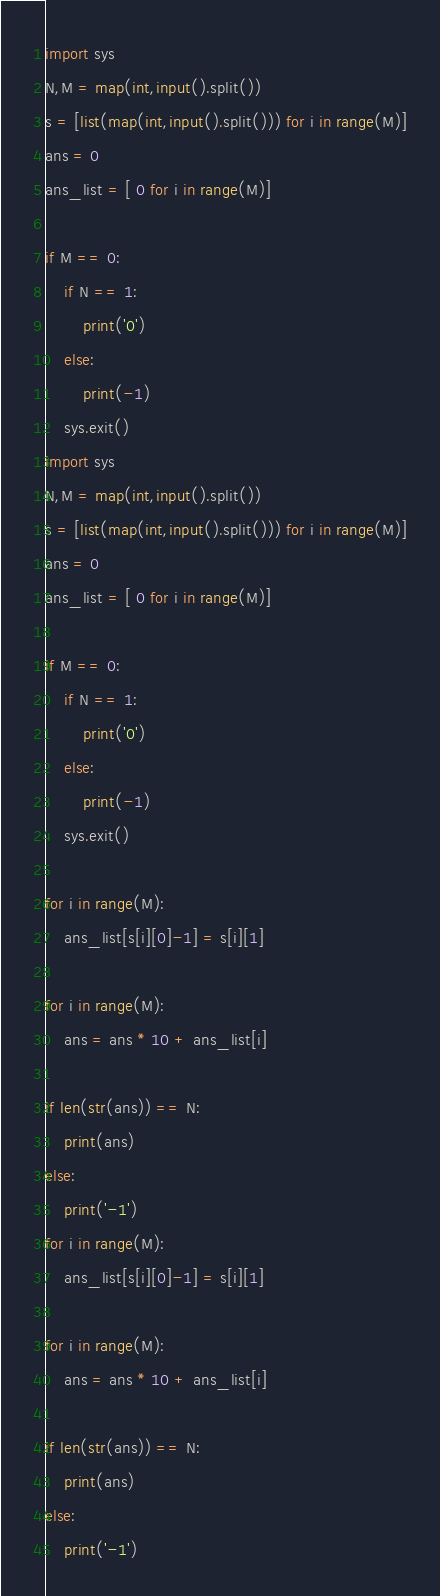Convert code to text. <code><loc_0><loc_0><loc_500><loc_500><_Python_>import sys
N,M = map(int,input().split())
s = [list(map(int,input().split())) for i in range(M)]
ans = 0
ans_list = [ 0 for i in range(M)]

if M == 0:
    if N == 1:
        print('0')
    else:
        print(-1)
    sys.exit()
import sys
N,M = map(int,input().split())
s = [list(map(int,input().split())) for i in range(M)]
ans = 0
ans_list = [ 0 for i in range(M)]

if M == 0:
    if N == 1:
        print('0')
    else:
        print(-1)
    sys.exit()

for i in range(M):
    ans_list[s[i][0]-1] = s[i][1]

for i in range(M):
    ans = ans * 10 + ans_list[i]

if len(str(ans)) == N:
    print(ans)
else:
    print('-1')
for i in range(M):
    ans_list[s[i][0]-1] = s[i][1]

for i in range(M):
    ans = ans * 10 + ans_list[i]

if len(str(ans)) == N:
    print(ans)
else:
    print('-1')</code> 